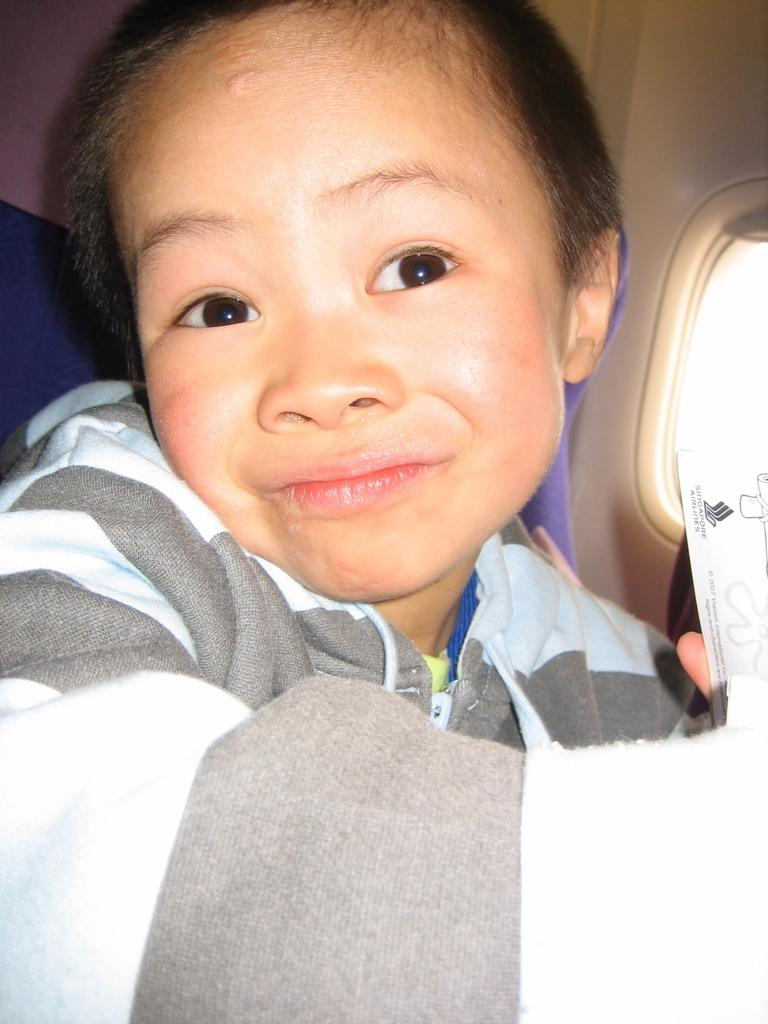What is the main subject of the image? The main subject of the image is a kid. Where is the kid located in the image? The kid is in a vehicle. What can be seen through the window in the image? There is a window visible in the image, which is likely to be a window of the vehicle. What is the chance of the kid taking a bath in the vehicle? There is no information about the kid taking a bath in the vehicle, so it cannot be determined from the image. 